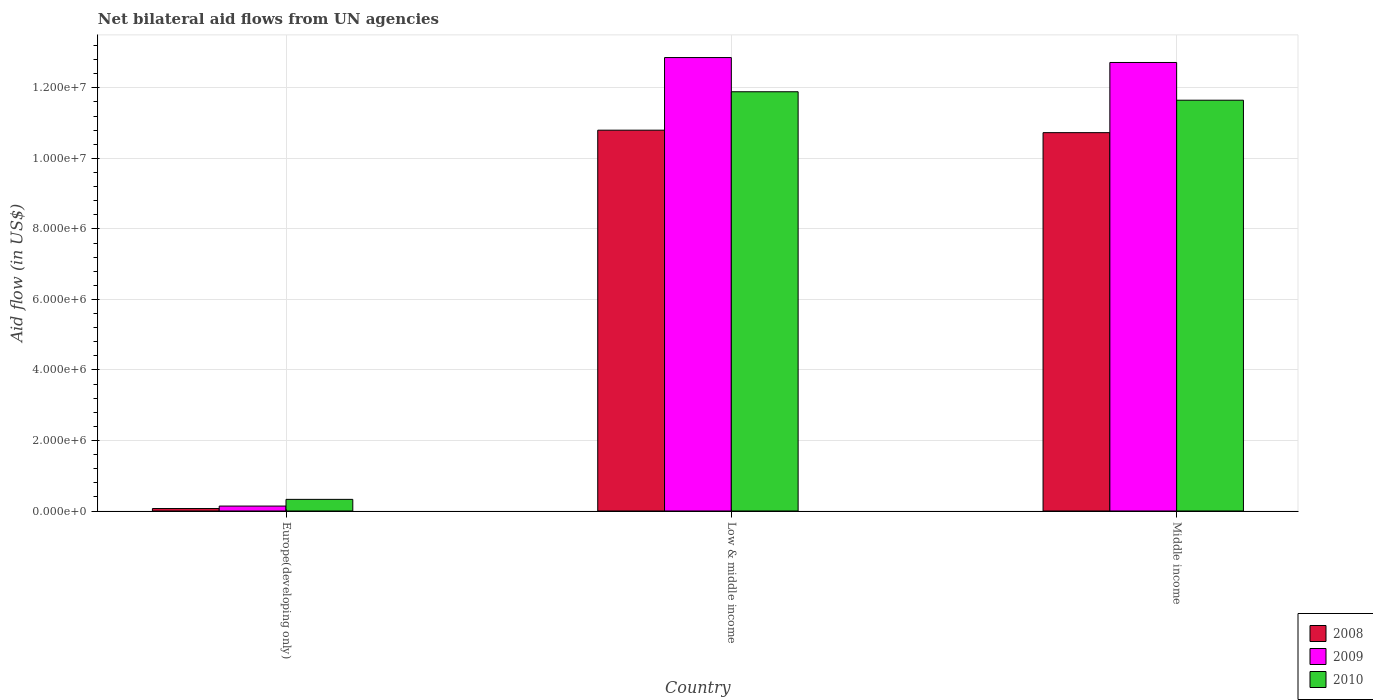Are the number of bars per tick equal to the number of legend labels?
Your answer should be very brief. Yes. Are the number of bars on each tick of the X-axis equal?
Keep it short and to the point. Yes. How many bars are there on the 2nd tick from the left?
Provide a succinct answer. 3. How many bars are there on the 1st tick from the right?
Your answer should be very brief. 3. What is the label of the 3rd group of bars from the left?
Provide a succinct answer. Middle income. What is the net bilateral aid flow in 2008 in Europe(developing only)?
Offer a terse response. 7.00e+04. Across all countries, what is the maximum net bilateral aid flow in 2008?
Your answer should be very brief. 1.08e+07. In which country was the net bilateral aid flow in 2010 maximum?
Your answer should be compact. Low & middle income. In which country was the net bilateral aid flow in 2008 minimum?
Give a very brief answer. Europe(developing only). What is the total net bilateral aid flow in 2008 in the graph?
Provide a succinct answer. 2.16e+07. What is the difference between the net bilateral aid flow in 2009 in Europe(developing only) and the net bilateral aid flow in 2010 in Middle income?
Offer a terse response. -1.15e+07. What is the average net bilateral aid flow in 2008 per country?
Make the answer very short. 7.20e+06. What is the difference between the net bilateral aid flow of/in 2009 and net bilateral aid flow of/in 2010 in Low & middle income?
Provide a short and direct response. 9.70e+05. What is the ratio of the net bilateral aid flow in 2010 in Low & middle income to that in Middle income?
Your answer should be very brief. 1.02. Is the difference between the net bilateral aid flow in 2009 in Europe(developing only) and Middle income greater than the difference between the net bilateral aid flow in 2010 in Europe(developing only) and Middle income?
Give a very brief answer. No. What is the difference between the highest and the lowest net bilateral aid flow in 2008?
Your answer should be compact. 1.07e+07. Is the sum of the net bilateral aid flow in 2008 in Europe(developing only) and Middle income greater than the maximum net bilateral aid flow in 2009 across all countries?
Your response must be concise. No. What does the 3rd bar from the right in Low & middle income represents?
Offer a terse response. 2008. How many bars are there?
Offer a very short reply. 9. What is the difference between two consecutive major ticks on the Y-axis?
Your answer should be compact. 2.00e+06. Where does the legend appear in the graph?
Offer a very short reply. Bottom right. What is the title of the graph?
Your response must be concise. Net bilateral aid flows from UN agencies. Does "2013" appear as one of the legend labels in the graph?
Your answer should be very brief. No. What is the label or title of the X-axis?
Your response must be concise. Country. What is the label or title of the Y-axis?
Make the answer very short. Aid flow (in US$). What is the Aid flow (in US$) in 2008 in Europe(developing only)?
Keep it short and to the point. 7.00e+04. What is the Aid flow (in US$) in 2008 in Low & middle income?
Provide a short and direct response. 1.08e+07. What is the Aid flow (in US$) in 2009 in Low & middle income?
Provide a short and direct response. 1.29e+07. What is the Aid flow (in US$) in 2010 in Low & middle income?
Provide a succinct answer. 1.19e+07. What is the Aid flow (in US$) of 2008 in Middle income?
Your answer should be very brief. 1.07e+07. What is the Aid flow (in US$) in 2009 in Middle income?
Give a very brief answer. 1.27e+07. What is the Aid flow (in US$) of 2010 in Middle income?
Make the answer very short. 1.16e+07. Across all countries, what is the maximum Aid flow (in US$) of 2008?
Your answer should be very brief. 1.08e+07. Across all countries, what is the maximum Aid flow (in US$) in 2009?
Give a very brief answer. 1.29e+07. Across all countries, what is the maximum Aid flow (in US$) of 2010?
Your answer should be compact. 1.19e+07. What is the total Aid flow (in US$) in 2008 in the graph?
Provide a succinct answer. 2.16e+07. What is the total Aid flow (in US$) in 2009 in the graph?
Provide a succinct answer. 2.57e+07. What is the total Aid flow (in US$) in 2010 in the graph?
Offer a very short reply. 2.39e+07. What is the difference between the Aid flow (in US$) of 2008 in Europe(developing only) and that in Low & middle income?
Offer a very short reply. -1.07e+07. What is the difference between the Aid flow (in US$) of 2009 in Europe(developing only) and that in Low & middle income?
Give a very brief answer. -1.27e+07. What is the difference between the Aid flow (in US$) in 2010 in Europe(developing only) and that in Low & middle income?
Offer a very short reply. -1.16e+07. What is the difference between the Aid flow (in US$) in 2008 in Europe(developing only) and that in Middle income?
Give a very brief answer. -1.07e+07. What is the difference between the Aid flow (in US$) in 2009 in Europe(developing only) and that in Middle income?
Offer a very short reply. -1.26e+07. What is the difference between the Aid flow (in US$) of 2010 in Europe(developing only) and that in Middle income?
Ensure brevity in your answer.  -1.13e+07. What is the difference between the Aid flow (in US$) in 2009 in Low & middle income and that in Middle income?
Offer a terse response. 1.40e+05. What is the difference between the Aid flow (in US$) of 2008 in Europe(developing only) and the Aid flow (in US$) of 2009 in Low & middle income?
Ensure brevity in your answer.  -1.28e+07. What is the difference between the Aid flow (in US$) in 2008 in Europe(developing only) and the Aid flow (in US$) in 2010 in Low & middle income?
Provide a short and direct response. -1.18e+07. What is the difference between the Aid flow (in US$) in 2009 in Europe(developing only) and the Aid flow (in US$) in 2010 in Low & middle income?
Keep it short and to the point. -1.18e+07. What is the difference between the Aid flow (in US$) in 2008 in Europe(developing only) and the Aid flow (in US$) in 2009 in Middle income?
Provide a succinct answer. -1.26e+07. What is the difference between the Aid flow (in US$) in 2008 in Europe(developing only) and the Aid flow (in US$) in 2010 in Middle income?
Offer a terse response. -1.16e+07. What is the difference between the Aid flow (in US$) in 2009 in Europe(developing only) and the Aid flow (in US$) in 2010 in Middle income?
Provide a short and direct response. -1.15e+07. What is the difference between the Aid flow (in US$) in 2008 in Low & middle income and the Aid flow (in US$) in 2009 in Middle income?
Your answer should be very brief. -1.92e+06. What is the difference between the Aid flow (in US$) of 2008 in Low & middle income and the Aid flow (in US$) of 2010 in Middle income?
Keep it short and to the point. -8.50e+05. What is the difference between the Aid flow (in US$) of 2009 in Low & middle income and the Aid flow (in US$) of 2010 in Middle income?
Your answer should be very brief. 1.21e+06. What is the average Aid flow (in US$) in 2008 per country?
Offer a very short reply. 7.20e+06. What is the average Aid flow (in US$) of 2009 per country?
Your response must be concise. 8.57e+06. What is the average Aid flow (in US$) of 2010 per country?
Make the answer very short. 7.96e+06. What is the difference between the Aid flow (in US$) of 2008 and Aid flow (in US$) of 2009 in Europe(developing only)?
Ensure brevity in your answer.  -7.00e+04. What is the difference between the Aid flow (in US$) of 2008 and Aid flow (in US$) of 2009 in Low & middle income?
Your answer should be compact. -2.06e+06. What is the difference between the Aid flow (in US$) of 2008 and Aid flow (in US$) of 2010 in Low & middle income?
Your response must be concise. -1.09e+06. What is the difference between the Aid flow (in US$) in 2009 and Aid flow (in US$) in 2010 in Low & middle income?
Give a very brief answer. 9.70e+05. What is the difference between the Aid flow (in US$) of 2008 and Aid flow (in US$) of 2009 in Middle income?
Ensure brevity in your answer.  -1.99e+06. What is the difference between the Aid flow (in US$) of 2008 and Aid flow (in US$) of 2010 in Middle income?
Your response must be concise. -9.20e+05. What is the difference between the Aid flow (in US$) of 2009 and Aid flow (in US$) of 2010 in Middle income?
Provide a short and direct response. 1.07e+06. What is the ratio of the Aid flow (in US$) of 2008 in Europe(developing only) to that in Low & middle income?
Make the answer very short. 0.01. What is the ratio of the Aid flow (in US$) of 2009 in Europe(developing only) to that in Low & middle income?
Your response must be concise. 0.01. What is the ratio of the Aid flow (in US$) in 2010 in Europe(developing only) to that in Low & middle income?
Offer a very short reply. 0.03. What is the ratio of the Aid flow (in US$) in 2008 in Europe(developing only) to that in Middle income?
Keep it short and to the point. 0.01. What is the ratio of the Aid flow (in US$) of 2009 in Europe(developing only) to that in Middle income?
Make the answer very short. 0.01. What is the ratio of the Aid flow (in US$) of 2010 in Europe(developing only) to that in Middle income?
Provide a succinct answer. 0.03. What is the ratio of the Aid flow (in US$) in 2010 in Low & middle income to that in Middle income?
Provide a succinct answer. 1.02. What is the difference between the highest and the second highest Aid flow (in US$) of 2008?
Keep it short and to the point. 7.00e+04. What is the difference between the highest and the second highest Aid flow (in US$) in 2010?
Your answer should be very brief. 2.40e+05. What is the difference between the highest and the lowest Aid flow (in US$) of 2008?
Offer a very short reply. 1.07e+07. What is the difference between the highest and the lowest Aid flow (in US$) in 2009?
Offer a very short reply. 1.27e+07. What is the difference between the highest and the lowest Aid flow (in US$) in 2010?
Make the answer very short. 1.16e+07. 